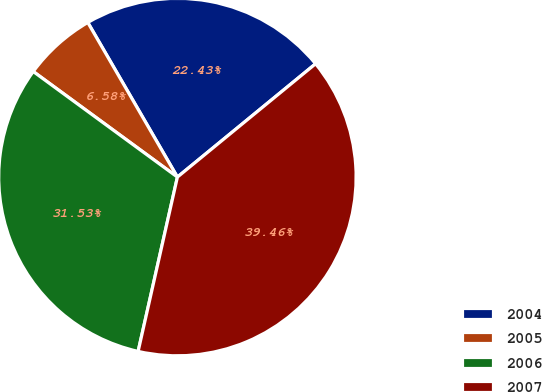Convert chart. <chart><loc_0><loc_0><loc_500><loc_500><pie_chart><fcel>2004<fcel>2005<fcel>2006<fcel>2007<nl><fcel>22.43%<fcel>6.58%<fcel>31.53%<fcel>39.46%<nl></chart> 